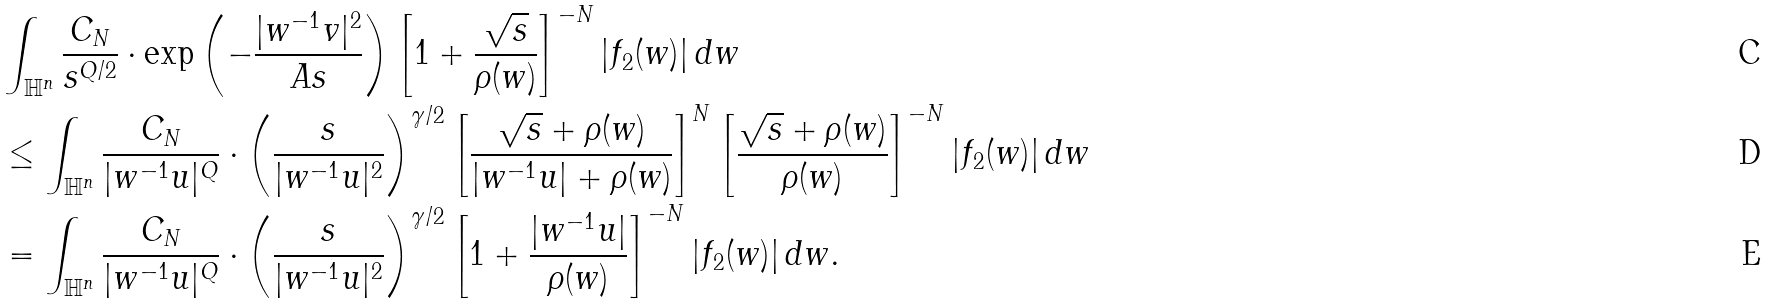<formula> <loc_0><loc_0><loc_500><loc_500>& \int _ { \mathbb { H } ^ { n } } \frac { C _ { N } } { s ^ { Q / 2 } } \cdot \exp \left ( - \frac { | w ^ { - 1 } v | ^ { 2 } } { A s } \right ) \left [ 1 + \frac { \sqrt { s } } { \rho ( w ) } \right ] ^ { - N } | f _ { 2 } ( w ) | \, d w \\ & \leq \int _ { \mathbb { H } ^ { n } } \frac { C _ { N } } { | w ^ { - 1 } u | ^ { Q } } \cdot \left ( \frac { s } { | w ^ { - 1 } u | ^ { 2 } } \right ) ^ { \gamma / 2 } \left [ \frac { \sqrt { s } + \rho ( w ) } { | w ^ { - 1 } u | + \rho ( w ) } \right ] ^ { N } \left [ \frac { \sqrt { s } + \rho ( w ) } { \rho ( w ) } \right ] ^ { - N } | f _ { 2 } ( w ) | \, d w \\ & = \int _ { \mathbb { H } ^ { n } } \frac { C _ { N } } { | w ^ { - 1 } u | ^ { Q } } \cdot \left ( \frac { s } { | w ^ { - 1 } u | ^ { 2 } } \right ) ^ { \gamma / 2 } \left [ 1 + \frac { | w ^ { - 1 } u | } { \rho ( w ) } \right ] ^ { - N } | f _ { 2 } ( w ) | \, d w .</formula> 